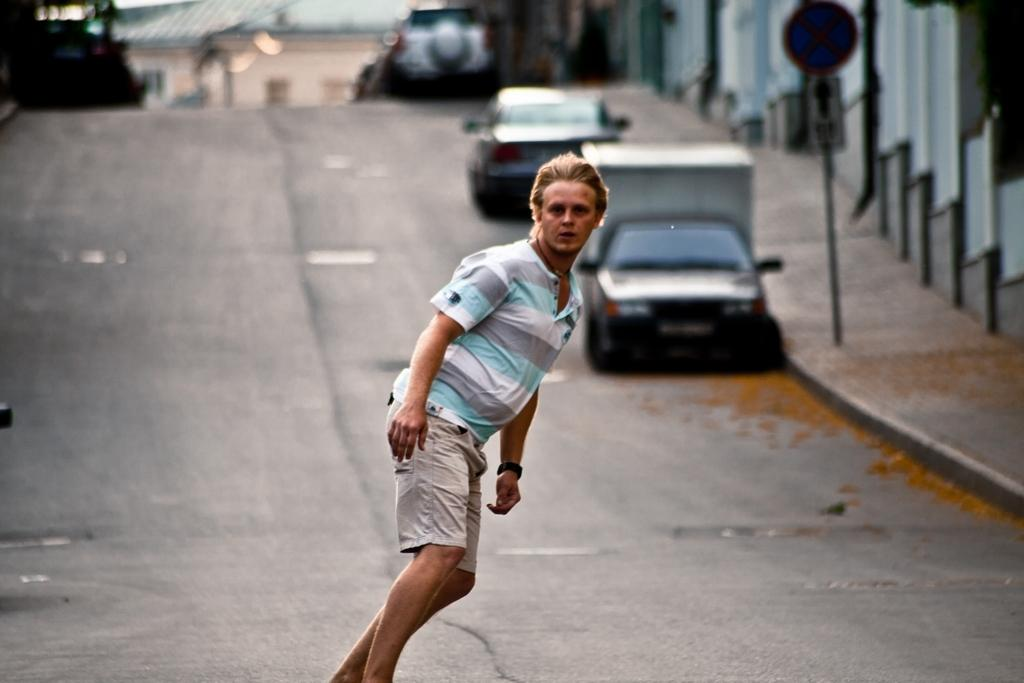Who is the main subject in the image? There is a person in the center of the image. Where is the person located? The person is on the road. What else can be seen in the image besides the person? There are vehicles and a sign board in the image. What is visible in the background of the image? There is a building in the background of the image. What type of hat is the dog wearing in the image? There is no dog or hat present in the image. 